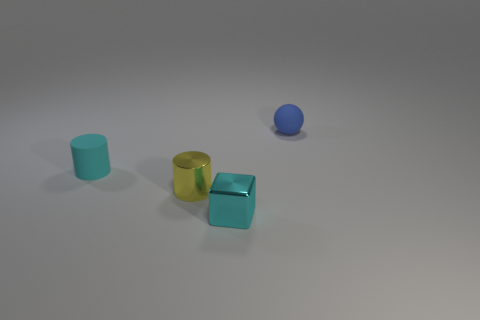Add 3 small blue shiny cylinders. How many objects exist? 7 Subtract all spheres. How many objects are left? 3 Add 1 small metal cubes. How many small metal cubes are left? 2 Add 3 tiny objects. How many tiny objects exist? 7 Subtract 1 cyan cylinders. How many objects are left? 3 Subtract all small balls. Subtract all matte balls. How many objects are left? 2 